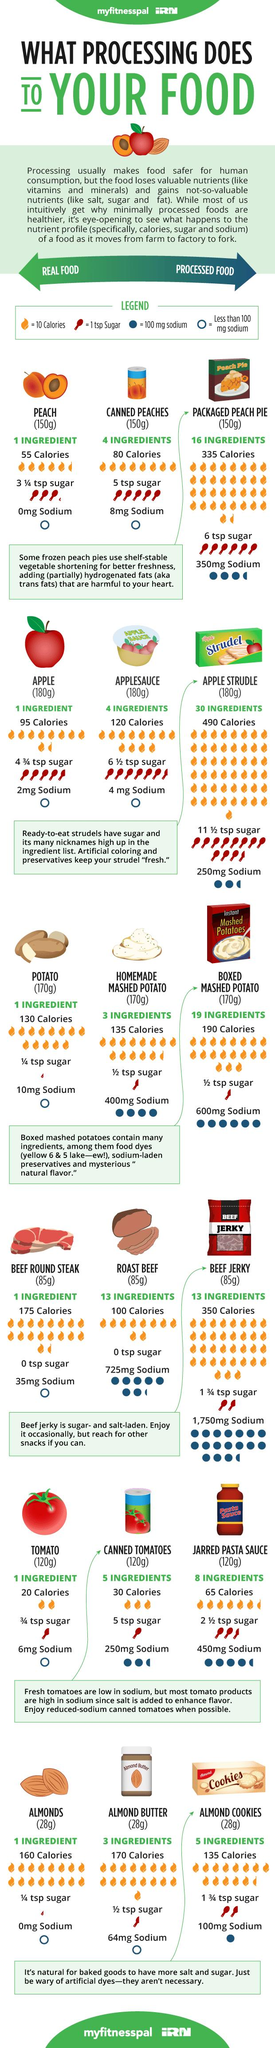Identify some key points in this picture. Canned peaches contain approximately 80 calories per serving. The tomato paste in canned tomatoes contains five ingredients. There are 13 ingredients in roast beef. Almond butter contains three ingredients. Applesauce contains 120 calories. 